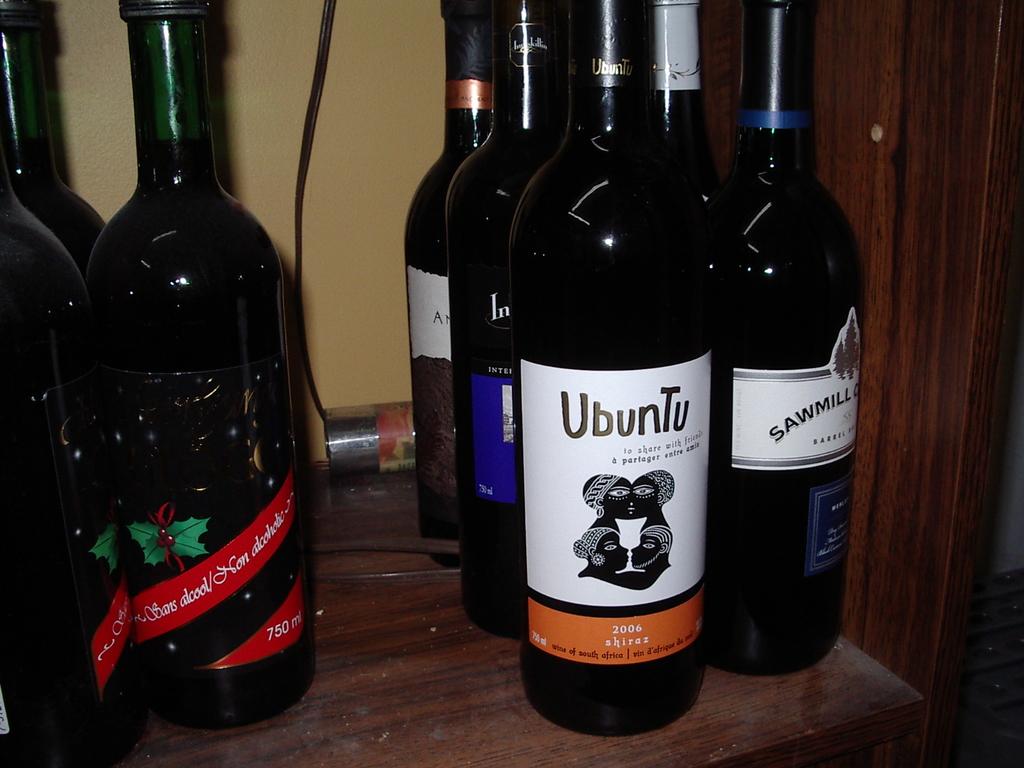What type of wine does ubuntu make?
Provide a succinct answer. Shiraz. 